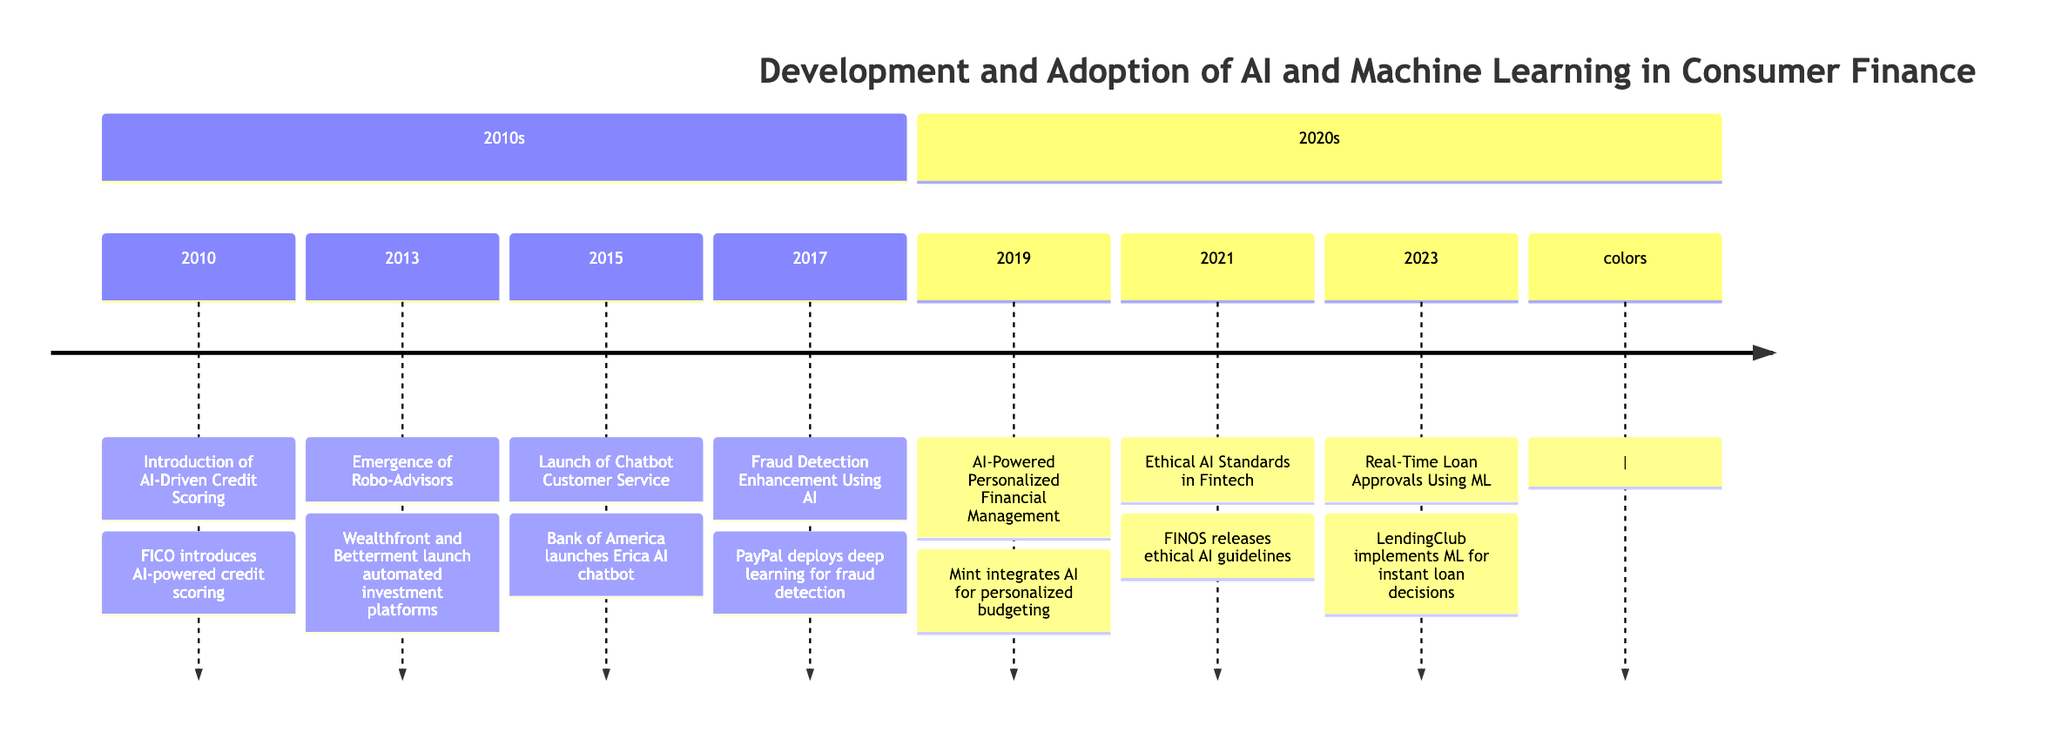What event marks the introduction of AI in credit scoring? The diagram indicates that in 2010, the event marked is "Introduction of AI-Driven Credit Scoring." This event was introduced by FICO, focusing on AI-powered credit scoring models.
Answer: Introduction of AI-Driven Credit Scoring Which platform launched in 2013 for automated investment? Referring to the timeline, in 2013, the event listed is the "Emergence of Robo-Advisors" with Wealthfront and Betterment launching automated investment platforms.
Answer: Robo-Advisors What year did Bank of America launch its AI-driven chatbot? The timeline specifies that the event "Launch of Chatbot Customer Service" is noted for the year 2015, indicating when Bank of America launched its chatbot named Erica.
Answer: 2015 Which company enhanced fraud detection using AI in 2017? According to the diagram, the event "Fraud Detection Enhancement Using AI" in 2017 is associated with PayPal, which deployed deep learning models to improve its fraud detection capabilities.
Answer: PayPal What is the significance of the 2021 ethical AI standards? The timeline discusses the “Ethical AI Standards in Fintech” event in 2021, released by the Fintech Open Source Foundation, promoting fairness and transparency in AI use.
Answer: Ethical AI Standards How many significant technological breakthroughs are listed before 2020? Analyzing the timeline, the years 2010, 2013, 2015, and 2017 all mark separate events before 2020, totaling four significant breakthroughs.
Answer: 4 What significant improvement in customer satisfaction was achieved in 2023? The event in 2023 states "Real-Time Loan Approvals Using ML," indicating that LendingClub implemented machine learning for quicker loan processing, enhancing customer satisfaction.
Answer: Real-Time Loan Approvals Which event occurred immediately before the deployment of AI in personalized financial management? The timeline shows that the event "AI-Powered Personalized Financial Management" occurred in 2019 and was preceded by "Ethical AI Standards in Fintech" in 2021, hence the direct predecessor event is in 2019.
Answer: AI-Powered Personalized Financial Management What technological capability did PayPal improve in 2017? The diagram indicates that in 2017, PayPal enhanced its "Fraud Detection" capabilities by utilizing AI, specifically deep learning models to reduce false positives.
Answer: Fraud Detection 